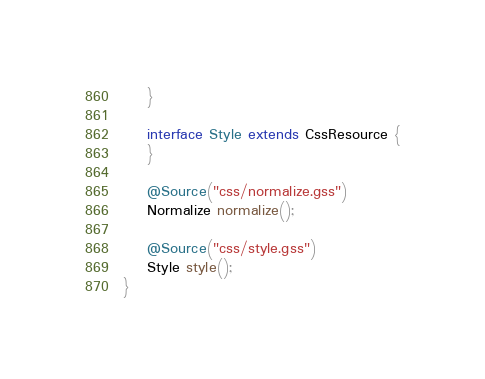<code> <loc_0><loc_0><loc_500><loc_500><_Java_>    }

    interface Style extends CssResource {
    }

    @Source("css/normalize.gss")
    Normalize normalize();

    @Source("css/style.gss")
    Style style();
}
</code> 